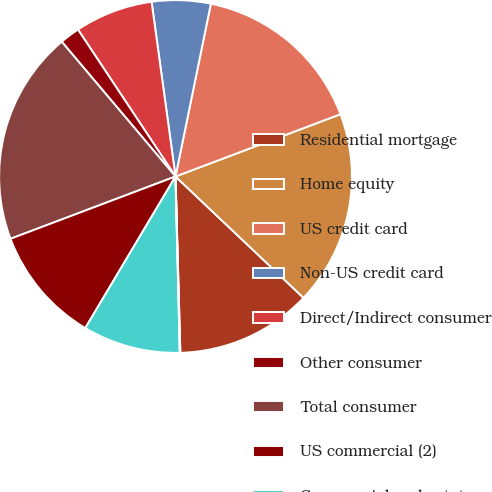Convert chart to OTSL. <chart><loc_0><loc_0><loc_500><loc_500><pie_chart><fcel>Residential mortgage<fcel>Home equity<fcel>US credit card<fcel>Non-US credit card<fcel>Direct/Indirect consumer<fcel>Other consumer<fcel>Total consumer<fcel>US commercial (2)<fcel>Commercial real estate<fcel>Commercial lease financing<nl><fcel>12.49%<fcel>17.82%<fcel>16.04%<fcel>5.38%<fcel>7.16%<fcel>1.83%<fcel>19.59%<fcel>10.71%<fcel>8.93%<fcel>0.05%<nl></chart> 